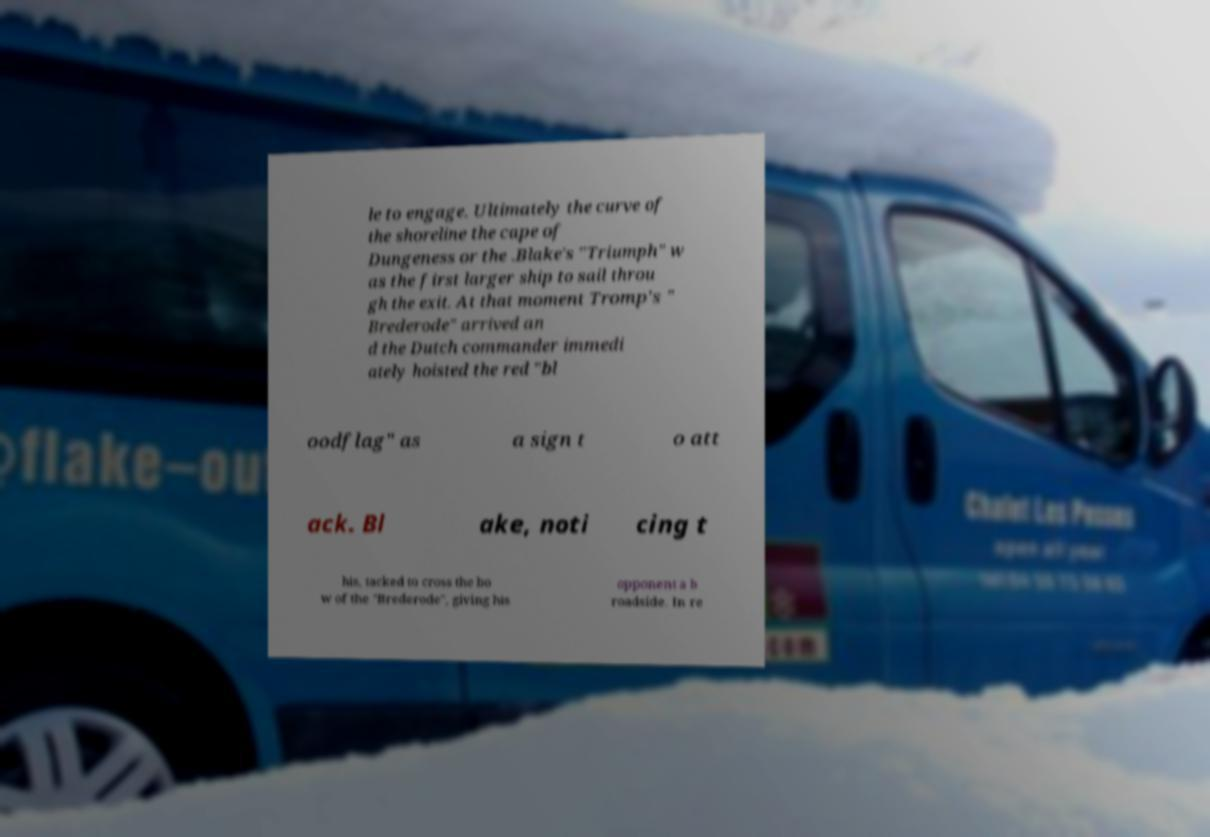Please identify and transcribe the text found in this image. le to engage. Ultimately the curve of the shoreline the cape of Dungeness or the .Blake's "Triumph" w as the first larger ship to sail throu gh the exit. At that moment Tromp's " Brederode" arrived an d the Dutch commander immedi ately hoisted the red "bl oodflag" as a sign t o att ack. Bl ake, noti cing t his, tacked to cross the bo w of the "Brederode", giving his opponent a b roadside. In re 